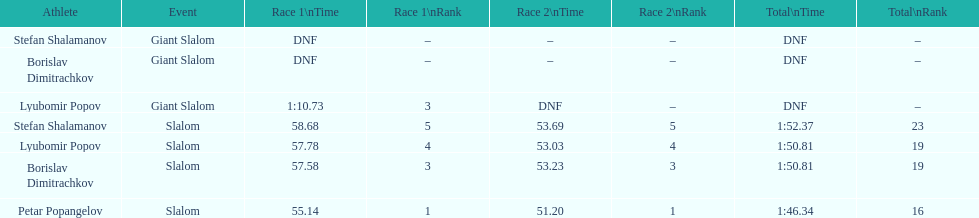How many athletes are there total? 4. Give me the full table as a dictionary. {'header': ['Athlete', 'Event', 'Race 1\\nTime', 'Race 1\\nRank', 'Race 2\\nTime', 'Race 2\\nRank', 'Total\\nTime', 'Total\\nRank'], 'rows': [['Stefan Shalamanov', 'Giant Slalom', 'DNF', '–', '–', '–', 'DNF', '–'], ['Borislav Dimitrachkov', 'Giant Slalom', 'DNF', '–', '–', '–', 'DNF', '–'], ['Lyubomir Popov', 'Giant Slalom', '1:10.73', '3', 'DNF', '–', 'DNF', '–'], ['Stefan Shalamanov', 'Slalom', '58.68', '5', '53.69', '5', '1:52.37', '23'], ['Lyubomir Popov', 'Slalom', '57.78', '4', '53.03', '4', '1:50.81', '19'], ['Borislav Dimitrachkov', 'Slalom', '57.58', '3', '53.23', '3', '1:50.81', '19'], ['Petar Popangelov', 'Slalom', '55.14', '1', '51.20', '1', '1:46.34', '16']]} 